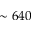<formula> <loc_0><loc_0><loc_500><loc_500>\sim 6 4 0</formula> 